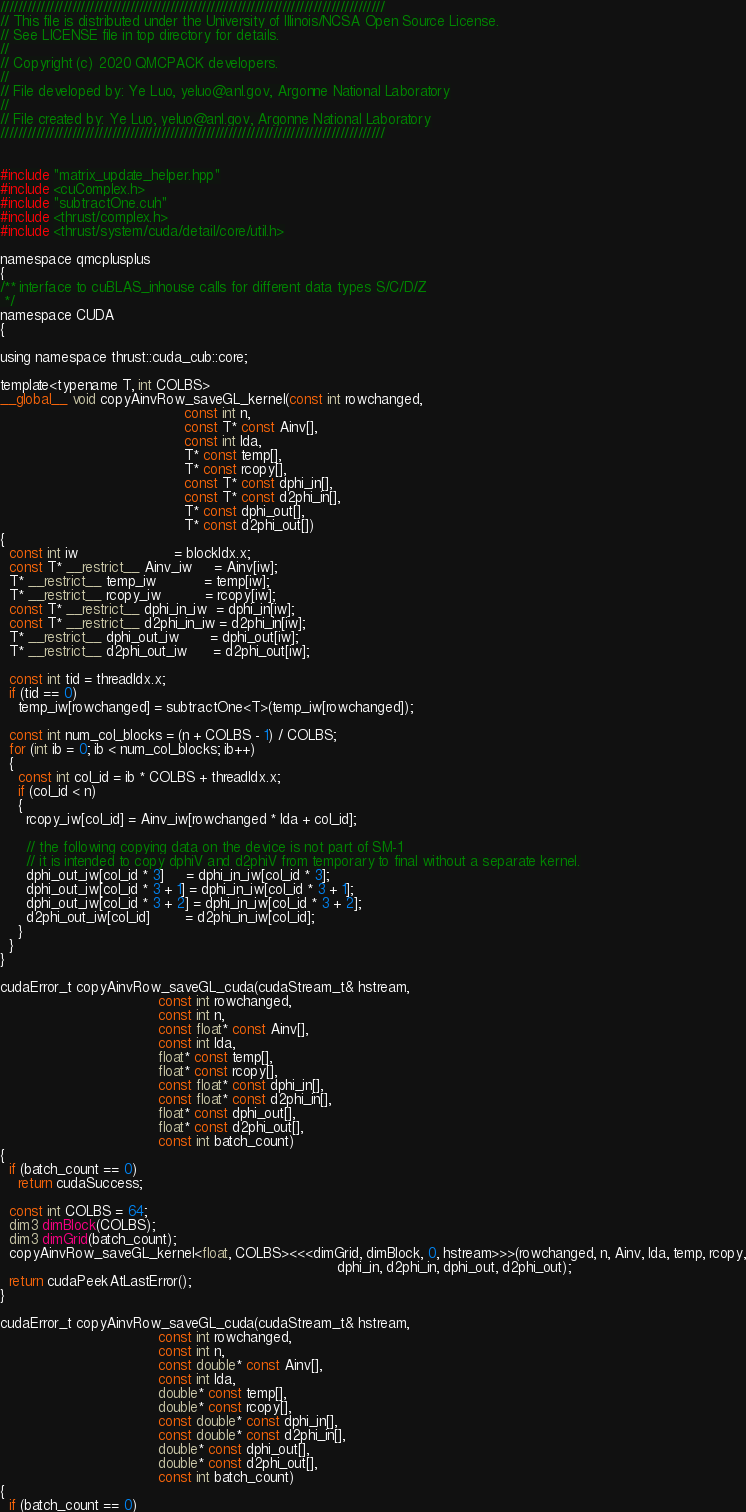<code> <loc_0><loc_0><loc_500><loc_500><_Cuda_>//////////////////////////////////////////////////////////////////////////////////////
// This file is distributed under the University of Illinois/NCSA Open Source License.
// See LICENSE file in top directory for details.
//
// Copyright (c) 2020 QMCPACK developers.
//
// File developed by: Ye Luo, yeluo@anl.gov, Argonne National Laboratory
//
// File created by: Ye Luo, yeluo@anl.gov, Argonne National Laboratory
//////////////////////////////////////////////////////////////////////////////////////


#include "matrix_update_helper.hpp"
#include <cuComplex.h>
#include "subtractOne.cuh"
#include <thrust/complex.h>
#include <thrust/system/cuda/detail/core/util.h>

namespace qmcplusplus
{
/** interface to cuBLAS_inhouse calls for different data types S/C/D/Z
 */
namespace CUDA
{

using namespace thrust::cuda_cub::core;

template<typename T, int COLBS>
__global__ void copyAinvRow_saveGL_kernel(const int rowchanged,
                                          const int n,
                                          const T* const Ainv[],
                                          const int lda,
                                          T* const temp[],
                                          T* const rcopy[],
                                          const T* const dphi_in[],
                                          const T* const d2phi_in[],
                                          T* const dphi_out[],
                                          T* const d2phi_out[])
{
  const int iw                      = blockIdx.x;
  const T* __restrict__ Ainv_iw     = Ainv[iw];
  T* __restrict__ temp_iw           = temp[iw];
  T* __restrict__ rcopy_iw          = rcopy[iw];
  const T* __restrict__ dphi_in_iw  = dphi_in[iw];
  const T* __restrict__ d2phi_in_iw = d2phi_in[iw];
  T* __restrict__ dphi_out_iw       = dphi_out[iw];
  T* __restrict__ d2phi_out_iw      = d2phi_out[iw];

  const int tid = threadIdx.x;
  if (tid == 0)
    temp_iw[rowchanged] = subtractOne<T>(temp_iw[rowchanged]);

  const int num_col_blocks = (n + COLBS - 1) / COLBS;
  for (int ib = 0; ib < num_col_blocks; ib++)
  {
    const int col_id = ib * COLBS + threadIdx.x;
    if (col_id < n)
    {
      rcopy_iw[col_id] = Ainv_iw[rowchanged * lda + col_id];

      // the following copying data on the device is not part of SM-1
      // it is intended to copy dphiV and d2phiV from temporary to final without a separate kernel.
      dphi_out_iw[col_id * 3]     = dphi_in_iw[col_id * 3];
      dphi_out_iw[col_id * 3 + 1] = dphi_in_iw[col_id * 3 + 1];
      dphi_out_iw[col_id * 3 + 2] = dphi_in_iw[col_id * 3 + 2];
      d2phi_out_iw[col_id]        = d2phi_in_iw[col_id];
    }
  }
}

cudaError_t copyAinvRow_saveGL_cuda(cudaStream_t& hstream,
                                    const int rowchanged,
                                    const int n,
                                    const float* const Ainv[],
                                    const int lda,
                                    float* const temp[],
                                    float* const rcopy[],
                                    const float* const dphi_in[],
                                    const float* const d2phi_in[],
                                    float* const dphi_out[],
                                    float* const d2phi_out[],
                                    const int batch_count)
{
  if (batch_count == 0)
    return cudaSuccess;

  const int COLBS = 64;
  dim3 dimBlock(COLBS);
  dim3 dimGrid(batch_count);
  copyAinvRow_saveGL_kernel<float, COLBS><<<dimGrid, dimBlock, 0, hstream>>>(rowchanged, n, Ainv, lda, temp, rcopy,
                                                                             dphi_in, d2phi_in, dphi_out, d2phi_out);
  return cudaPeekAtLastError();
}

cudaError_t copyAinvRow_saveGL_cuda(cudaStream_t& hstream,
                                    const int rowchanged,
                                    const int n,
                                    const double* const Ainv[],
                                    const int lda,
                                    double* const temp[],
                                    double* const rcopy[],
                                    const double* const dphi_in[],
                                    const double* const d2phi_in[],
                                    double* const dphi_out[],
                                    double* const d2phi_out[],
                                    const int batch_count)
{
  if (batch_count == 0)</code> 